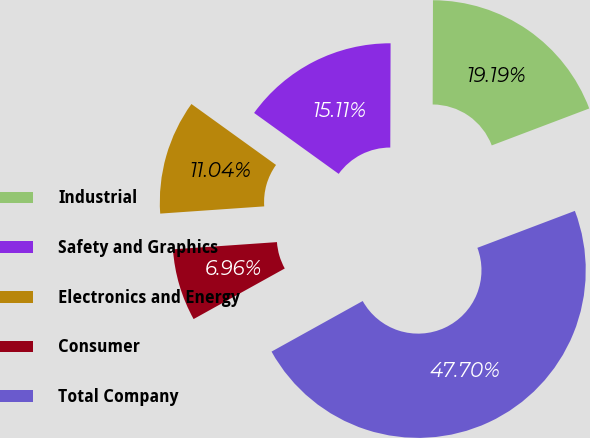Convert chart to OTSL. <chart><loc_0><loc_0><loc_500><loc_500><pie_chart><fcel>Industrial<fcel>Safety and Graphics<fcel>Electronics and Energy<fcel>Consumer<fcel>Total Company<nl><fcel>19.19%<fcel>15.11%<fcel>11.04%<fcel>6.96%<fcel>47.7%<nl></chart> 